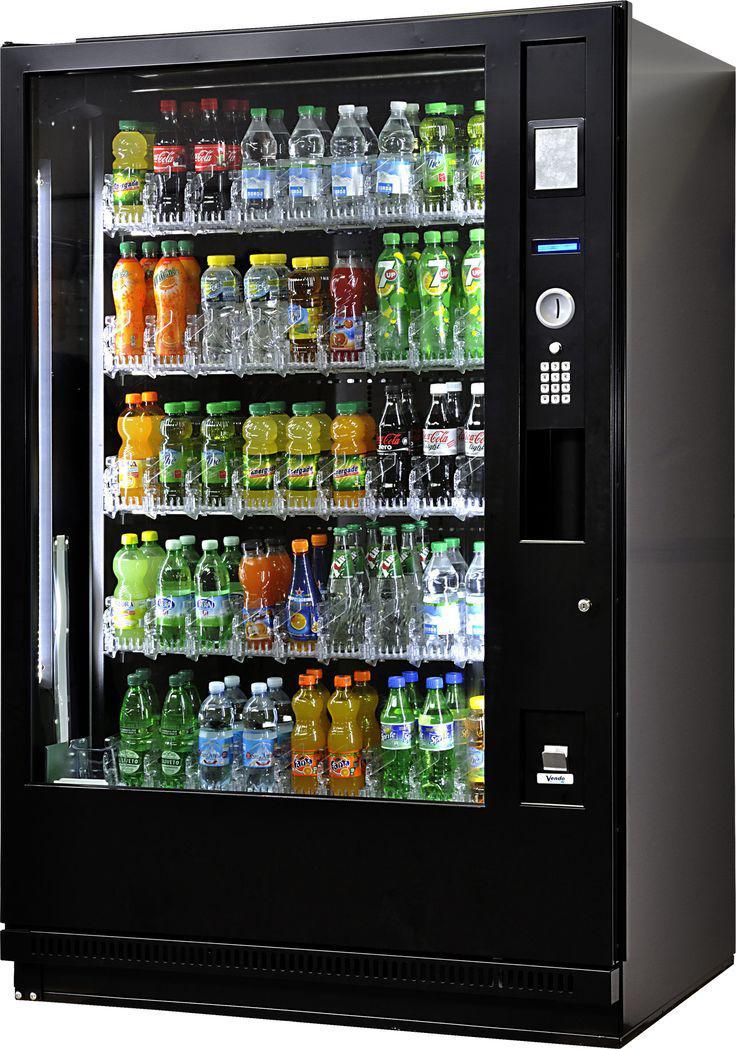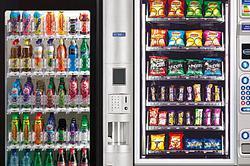The first image is the image on the left, the second image is the image on the right. Assess this claim about the two images: "At least one vending machine is loaded with drinks.". Correct or not? Answer yes or no. Yes. 